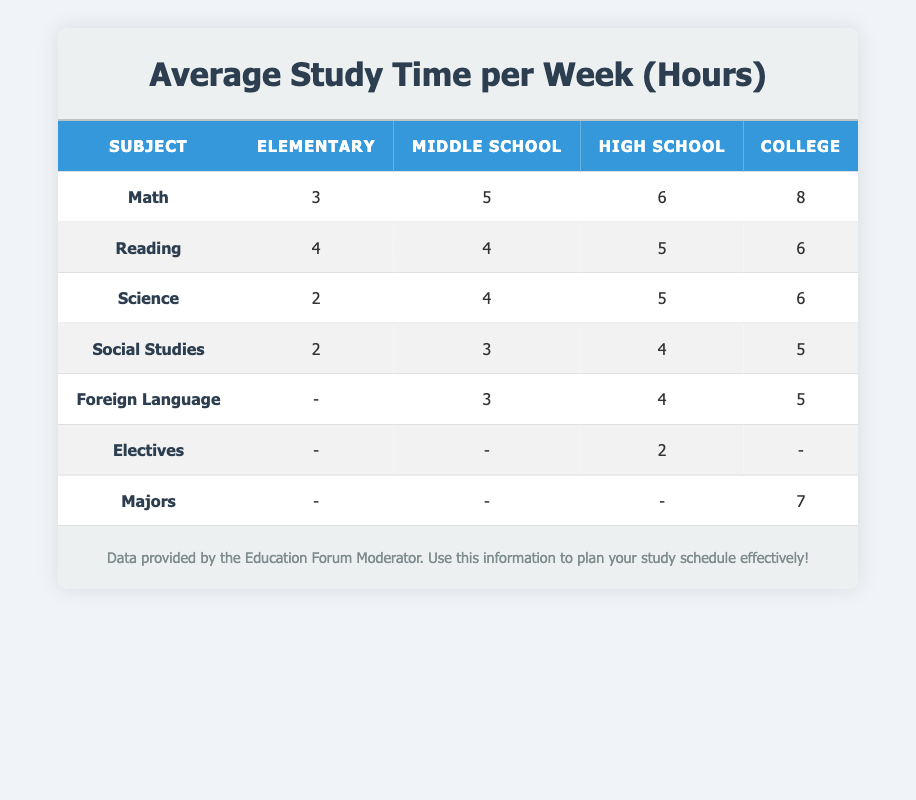What is the average study time for Math in High School? In the High School row, under the Math column, the average study time is given as 6 hours.
Answer: 6 How much time do Middle School students spend on Science compared to Social Studies? Middle School students spend 4 hours on Science and 3 hours on Social Studies. The difference is 4 - 3 = 1 hour, meaning they spend 1 hour more on Science.
Answer: 1 hour True or False: College students study more for Majors than for Math. In the College row, the study time for Majors is 7 hours, while for Math it is 8 hours. Since 7 is less than 8, the statement is false.
Answer: False What is the total study time for Reading in Elementary and Middle School combined? For Elementary, the study time for Reading is 4 hours. For Middle School, it is also 4 hours. Adding these together gives 4 + 4 = 8 hours.
Answer: 8 Which subject has the least amount of average study time in Elementary? In the Elementary category, looking across all subjects, Science and Social Studies both have the least average study time at 2 hours.
Answer: Science and Social Studies How much more time do College students spend on Science compared to Elementary students? College students spend 6 hours studying Science, while Elementary students spend 2 hours. The difference is 6 - 2 = 4 hours, indicating College students spend 4 hours more on Science.
Answer: 4 hours True or False: High School students do not study for Electives. In High School, the study time for Electives is indicated as 2 hours, confirming that they do study for Electives. Therefore, the statement is false.
Answer: False What is the average study time for Foreign Language across Middle School, High School, and College? The times for Foreign Language are 3 hours in Middle School, 4 hours in High School, and 5 hours in College. To find the average, add them: 3 + 4 + 5 = 12, then divide by 3, resulting in 12 / 3 = 4 hours.
Answer: 4 hours How does the average study time for Math in College compare to that in Middle School? In College, the average study time for Math is 8 hours, while in Middle School it is 5 hours. Subtracting these gives 8 - 5 = 3 hours, meaning College students study 3 hours more for Math.
Answer: 3 hours 